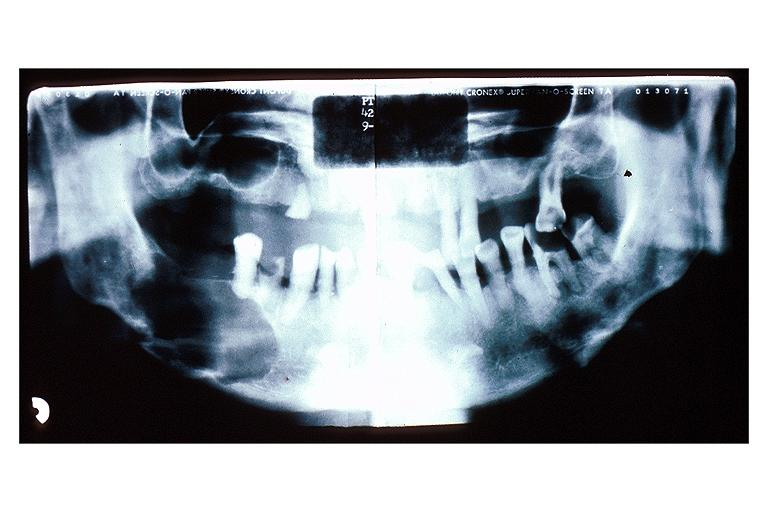s opened uterus and cervix with large cervical myoma protruding into vagina slide present?
Answer the question using a single word or phrase. No 